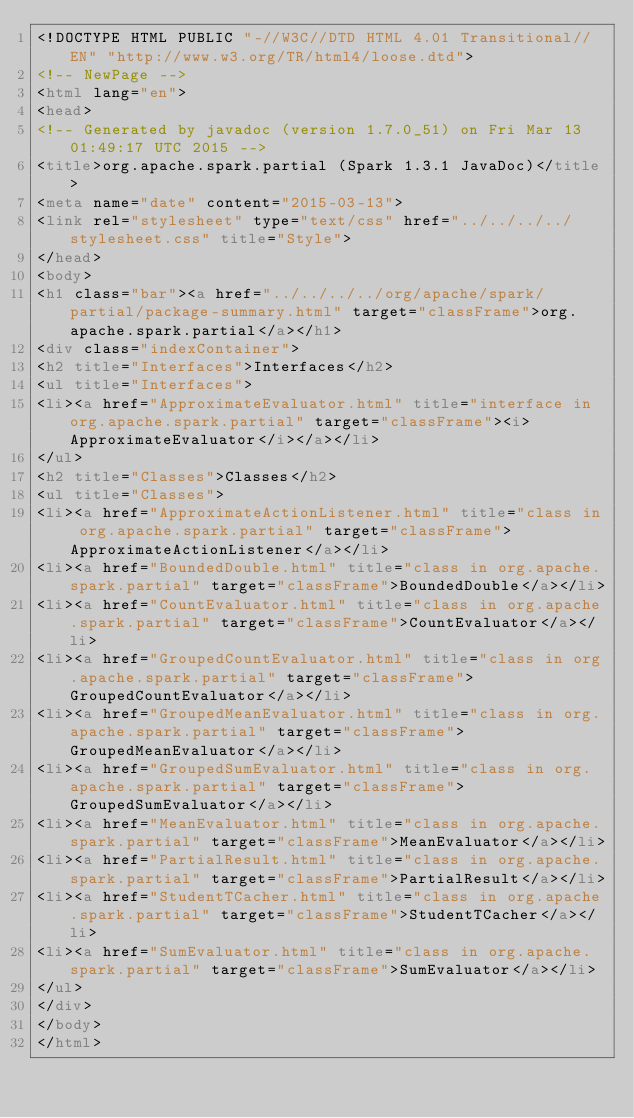<code> <loc_0><loc_0><loc_500><loc_500><_HTML_><!DOCTYPE HTML PUBLIC "-//W3C//DTD HTML 4.01 Transitional//EN" "http://www.w3.org/TR/html4/loose.dtd">
<!-- NewPage -->
<html lang="en">
<head>
<!-- Generated by javadoc (version 1.7.0_51) on Fri Mar 13 01:49:17 UTC 2015 -->
<title>org.apache.spark.partial (Spark 1.3.1 JavaDoc)</title>
<meta name="date" content="2015-03-13">
<link rel="stylesheet" type="text/css" href="../../../../stylesheet.css" title="Style">
</head>
<body>
<h1 class="bar"><a href="../../../../org/apache/spark/partial/package-summary.html" target="classFrame">org.apache.spark.partial</a></h1>
<div class="indexContainer">
<h2 title="Interfaces">Interfaces</h2>
<ul title="Interfaces">
<li><a href="ApproximateEvaluator.html" title="interface in org.apache.spark.partial" target="classFrame"><i>ApproximateEvaluator</i></a></li>
</ul>
<h2 title="Classes">Classes</h2>
<ul title="Classes">
<li><a href="ApproximateActionListener.html" title="class in org.apache.spark.partial" target="classFrame">ApproximateActionListener</a></li>
<li><a href="BoundedDouble.html" title="class in org.apache.spark.partial" target="classFrame">BoundedDouble</a></li>
<li><a href="CountEvaluator.html" title="class in org.apache.spark.partial" target="classFrame">CountEvaluator</a></li>
<li><a href="GroupedCountEvaluator.html" title="class in org.apache.spark.partial" target="classFrame">GroupedCountEvaluator</a></li>
<li><a href="GroupedMeanEvaluator.html" title="class in org.apache.spark.partial" target="classFrame">GroupedMeanEvaluator</a></li>
<li><a href="GroupedSumEvaluator.html" title="class in org.apache.spark.partial" target="classFrame">GroupedSumEvaluator</a></li>
<li><a href="MeanEvaluator.html" title="class in org.apache.spark.partial" target="classFrame">MeanEvaluator</a></li>
<li><a href="PartialResult.html" title="class in org.apache.spark.partial" target="classFrame">PartialResult</a></li>
<li><a href="StudentTCacher.html" title="class in org.apache.spark.partial" target="classFrame">StudentTCacher</a></li>
<li><a href="SumEvaluator.html" title="class in org.apache.spark.partial" target="classFrame">SumEvaluator</a></li>
</ul>
</div>
</body>
</html>
</code> 